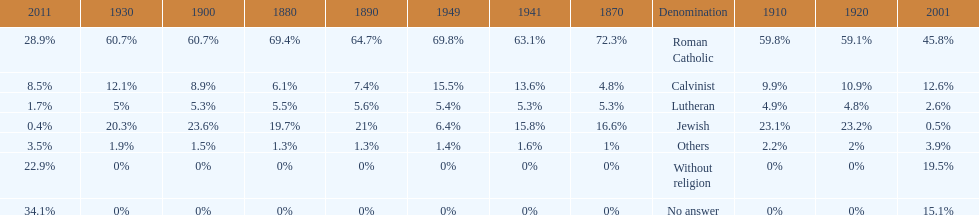Which religious denomination had a higher percentage in 1900, jewish or roman catholic? Roman Catholic. Write the full table. {'header': ['2011', '1930', '1900', '1880', '1890', '1949', '1941', '1870', 'Denomination', '1910', '1920', '2001'], 'rows': [['28.9%', '60.7%', '60.7%', '69.4%', '64.7%', '69.8%', '63.1%', '72.3%', 'Roman Catholic', '59.8%', '59.1%', '45.8%'], ['8.5%', '12.1%', '8.9%', '6.1%', '7.4%', '15.5%', '13.6%', '4.8%', 'Calvinist', '9.9%', '10.9%', '12.6%'], ['1.7%', '5%', '5.3%', '5.5%', '5.6%', '5.4%', '5.3%', '5.3%', 'Lutheran', '4.9%', '4.8%', '2.6%'], ['0.4%', '20.3%', '23.6%', '19.7%', '21%', '6.4%', '15.8%', '16.6%', 'Jewish', '23.1%', '23.2%', '0.5%'], ['3.5%', '1.9%', '1.5%', '1.3%', '1.3%', '1.4%', '1.6%', '1%', 'Others', '2.2%', '2%', '3.9%'], ['22.9%', '0%', '0%', '0%', '0%', '0%', '0%', '0%', 'Without religion', '0%', '0%', '19.5%'], ['34.1%', '0%', '0%', '0%', '0%', '0%', '0%', '0%', 'No answer', '0%', '0%', '15.1%']]} 